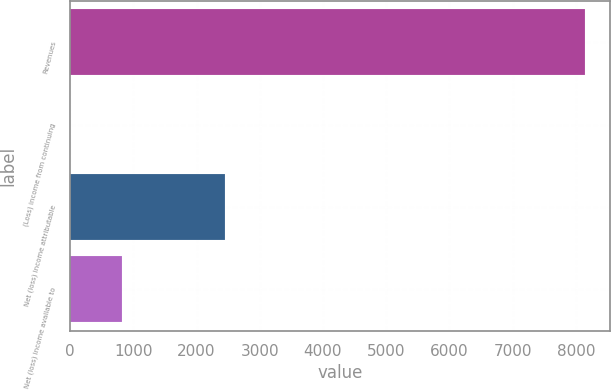<chart> <loc_0><loc_0><loc_500><loc_500><bar_chart><fcel>Revenues<fcel>(Loss) income from continuing<fcel>Net (loss) income attributable<fcel>Net (loss) income available to<nl><fcel>8139<fcel>1.27<fcel>2442.58<fcel>815.04<nl></chart> 